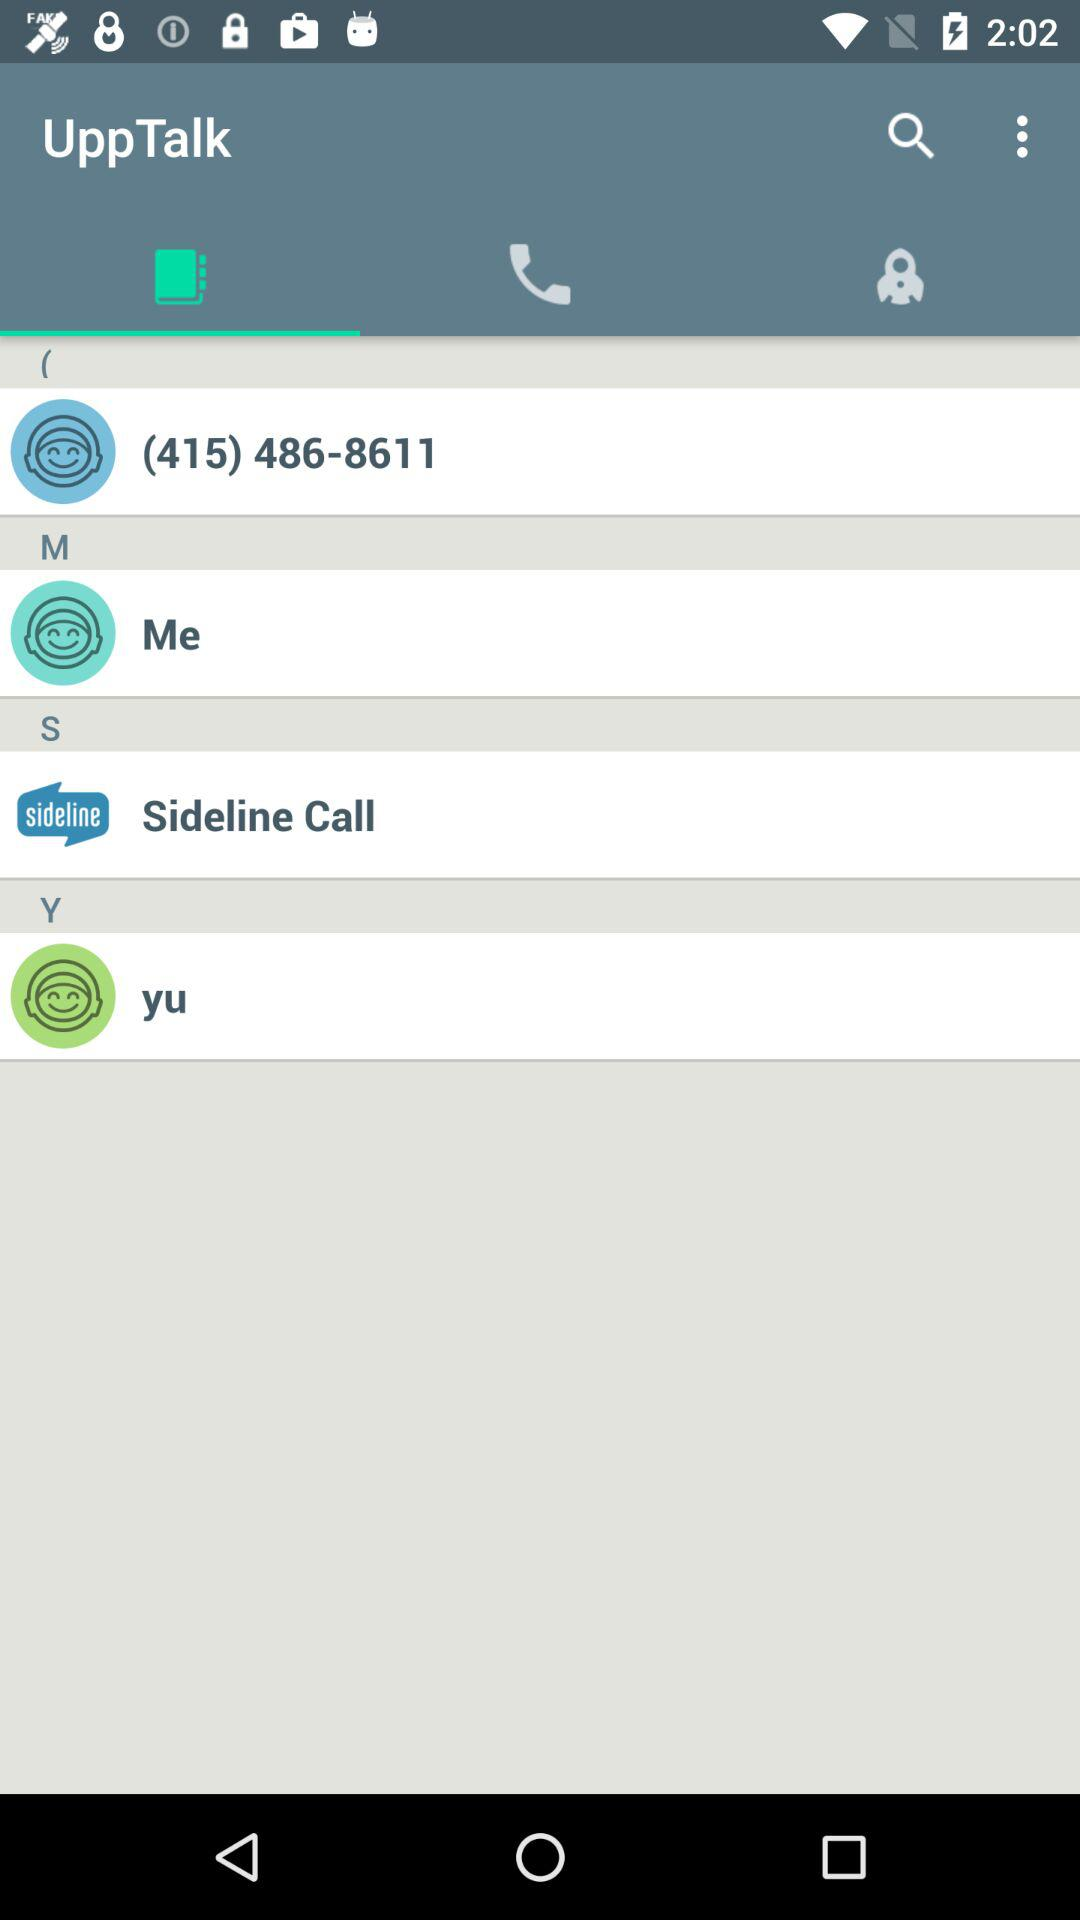What number is displayed? The displayed number is (415) 486-8611. 